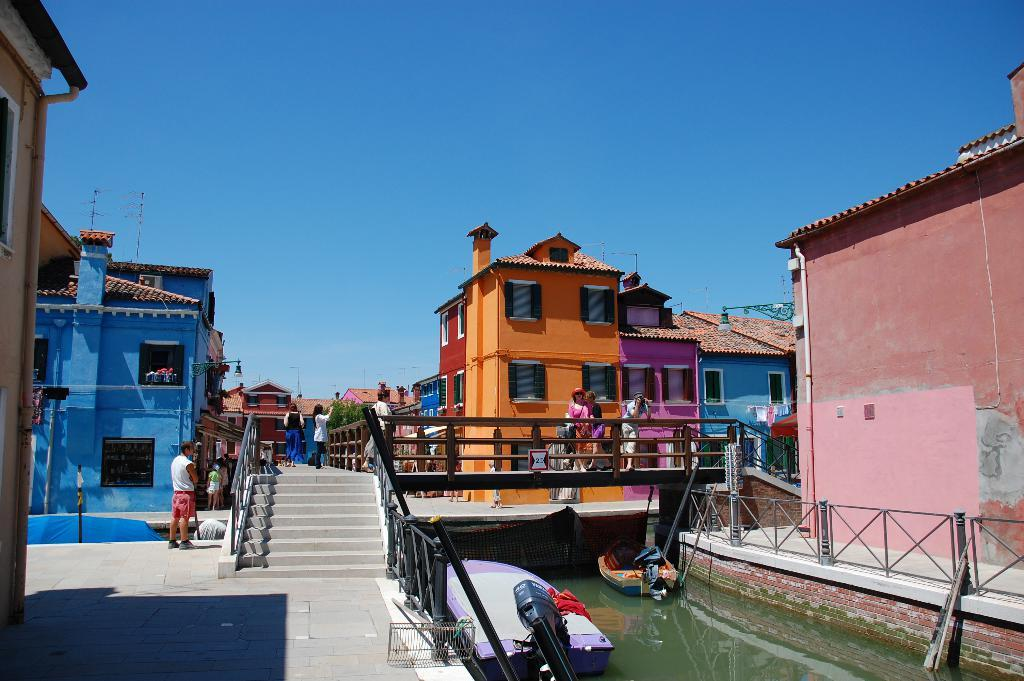What is on the water in the image? There are boats on the water in the image. What is the primary element visible in the image? Water is visible in the image. What architectural feature can be seen in the image? There are stairs and railings in the image. Who or what is present in the image? There are people present in the image. What can be seen in the background of the image? There are buildings in the background of the image. What type of steam is being produced by the horse in the image? There is no horse or steam present in the image. How does the respect shown by the people in the image affect the water? There is no mention of respect in the image, and it does not affect the water. 